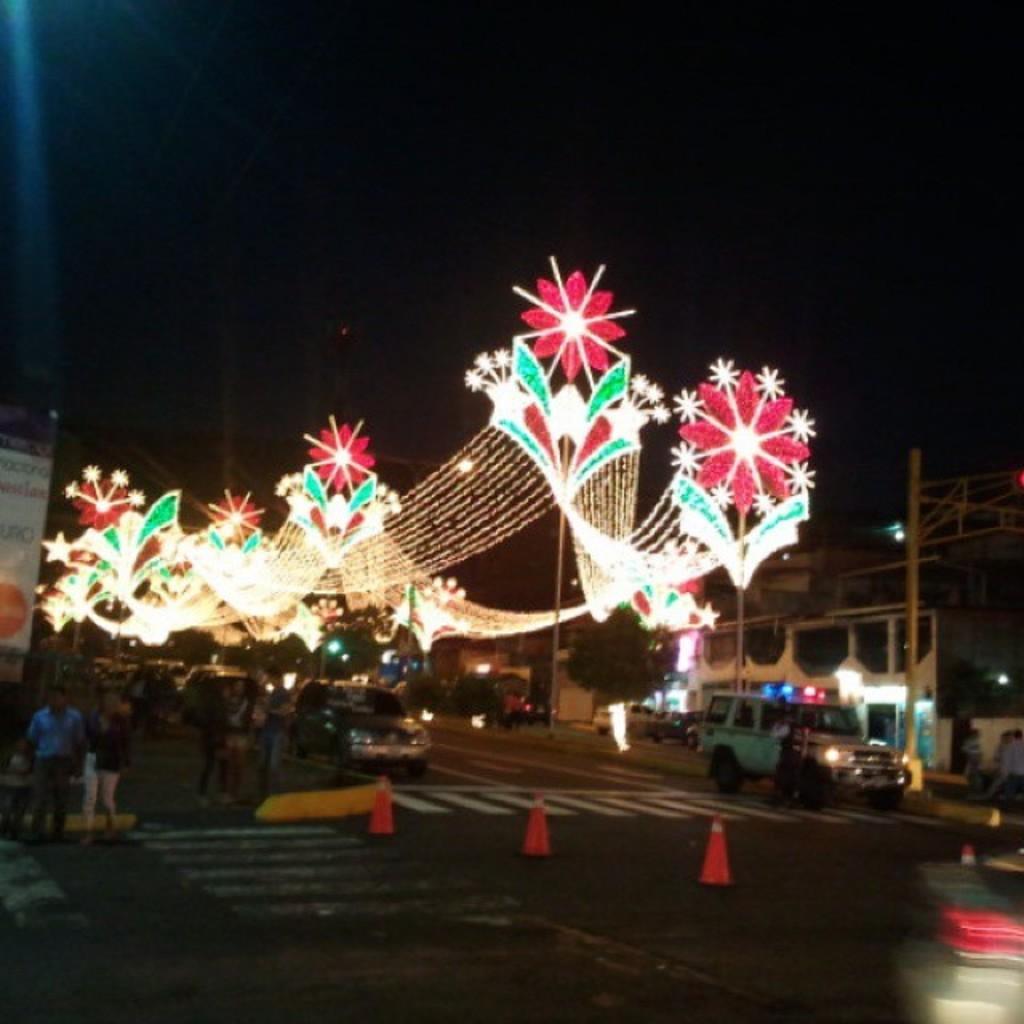Could you give a brief overview of what you see in this image? In this image we can see buildings, motor vehicles on the road, traffic cones, persons standing on the road, decor lights and sky. 